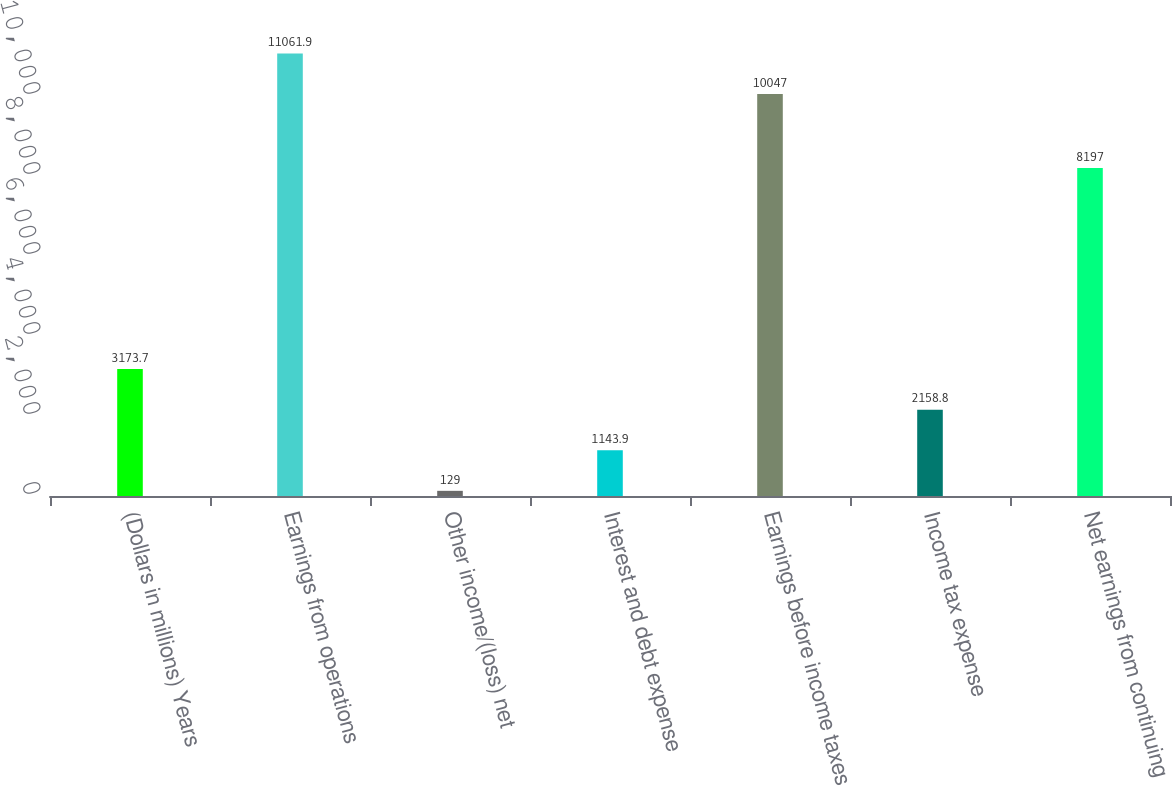Convert chart. <chart><loc_0><loc_0><loc_500><loc_500><bar_chart><fcel>(Dollars in millions) Years<fcel>Earnings from operations<fcel>Other income/(loss) net<fcel>Interest and debt expense<fcel>Earnings before income taxes<fcel>Income tax expense<fcel>Net earnings from continuing<nl><fcel>3173.7<fcel>11061.9<fcel>129<fcel>1143.9<fcel>10047<fcel>2158.8<fcel>8197<nl></chart> 